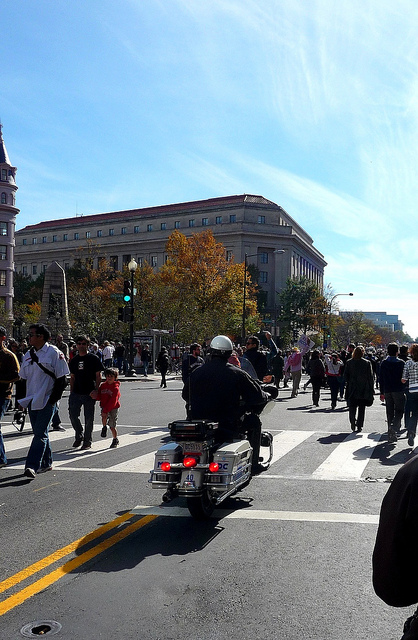Read all the text in this image. DC 